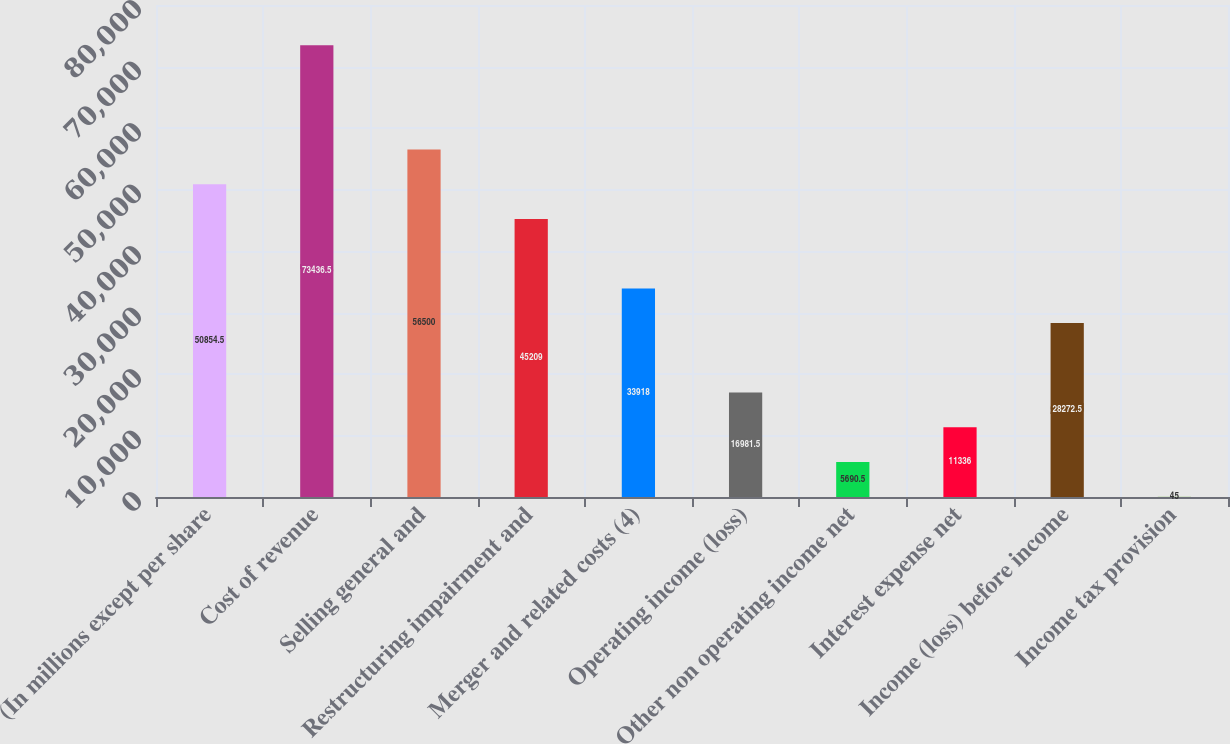Convert chart. <chart><loc_0><loc_0><loc_500><loc_500><bar_chart><fcel>(In millions except per share<fcel>Cost of revenue<fcel>Selling general and<fcel>Restructuring impairment and<fcel>Merger and related costs (4)<fcel>Operating income (loss)<fcel>Other non operating income net<fcel>Interest expense net<fcel>Income (loss) before income<fcel>Income tax provision<nl><fcel>50854.5<fcel>73436.5<fcel>56500<fcel>45209<fcel>33918<fcel>16981.5<fcel>5690.5<fcel>11336<fcel>28272.5<fcel>45<nl></chart> 